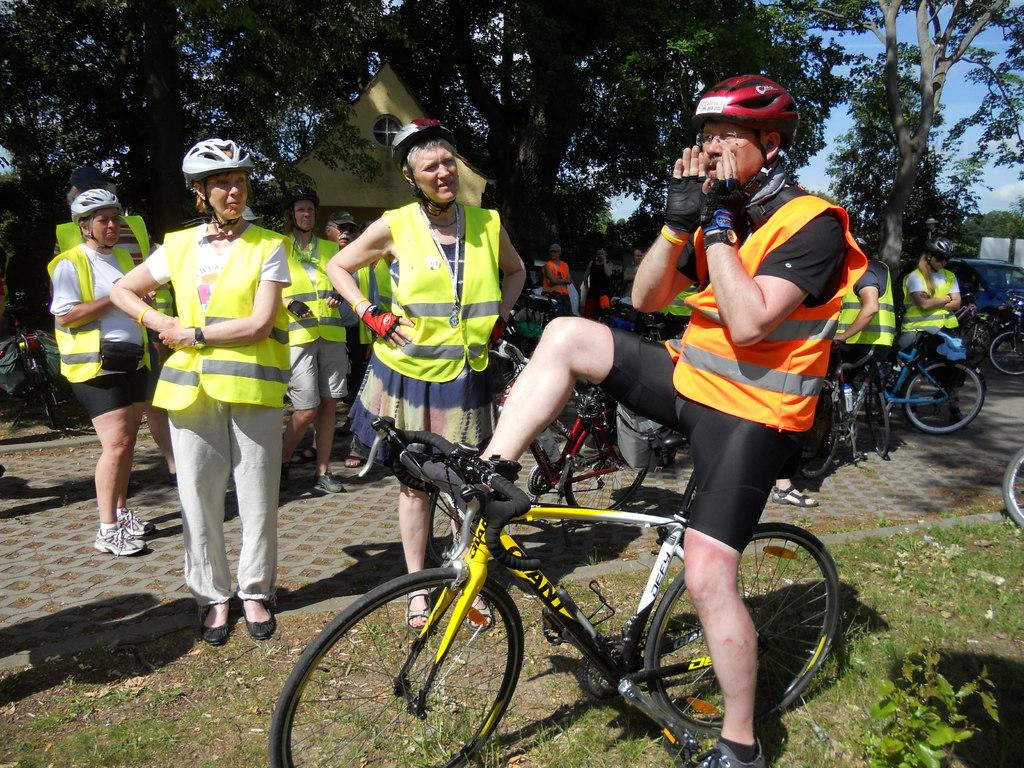What are the people in the image doing? There is a group of people in the image, with some standing and others sitting on bicycles. What can be seen in the background of the image? There are trees visible in the background. What else is present in the image besides the people and trees? Vehicles are present on the road in the image. What does your aunt believe about the people in the image? There is no mention of an aunt or any beliefs in the image or the provided facts, so we cannot answer this question. 